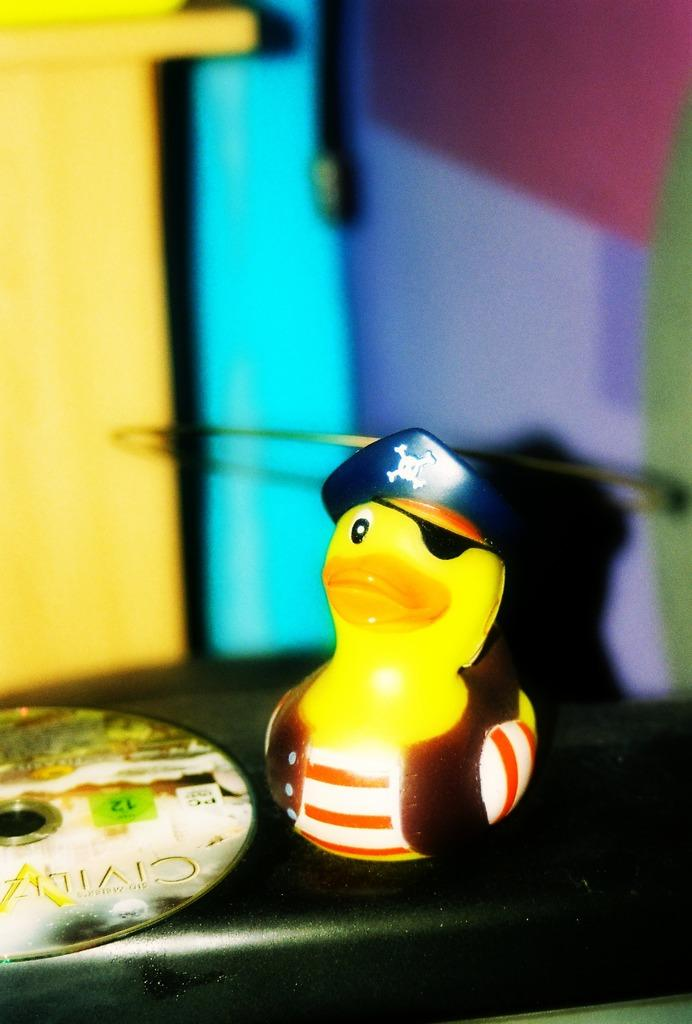What type of toy is present in the image? There is a small yellow duck toy in the image. Where is the duck toy located? The duck toy is placed on a table top. Can you describe the background of the image? The background of the image is blurred. What type of request is the duck toy making in the image? The duck toy is not making any request in the image, as it is an inanimate object and cannot communicate verbally. 